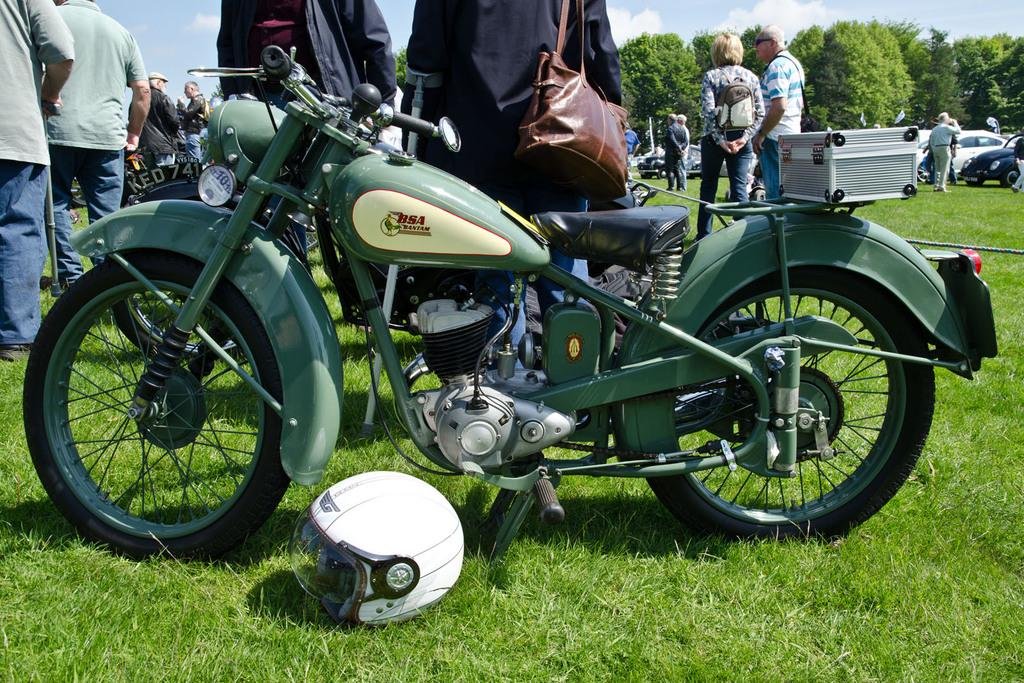How many people are in the image? There is a group of people standing in the image. What are two of the people wearing? Two persons are wearing bags. What can be seen in the distance in the image? There are trees visible in the distance. What is the condition of the sky in the image? The sky is visible with clouds. What type of objects are present in the image? There are vehicles in the image. Where is a helmet located in the image? A helmet is present on the grass. Where is the rabbit playing the drum in the image? There is no rabbit or drum present in the image. 